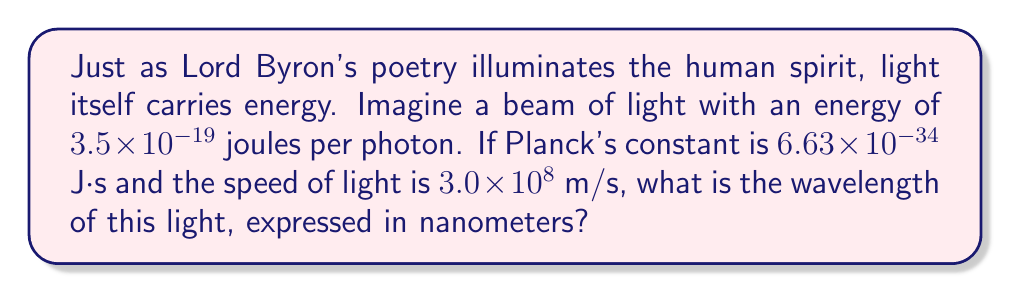Solve this math problem. Let's approach this step-by-step, much like we would analyze a poem:

1) We'll use the energy-frequency relationship, which is given by:
   $$E = hf$$
   where $E$ is energy, $h$ is Planck's constant, and $f$ is frequency.

2) We're given the energy $E = 3.5 \times 10^{-19}$ J, so let's solve for frequency:
   $$f = \frac{E}{h} = \frac{3.5 \times 10^{-19}}{6.63 \times 10^{-34}} = 5.28 \times 10^{14} \text{ Hz}$$

3) Now, we can use the wave equation to relate frequency to wavelength:
   $$c = f\lambda$$
   where $c$ is the speed of light and $\lambda$ is wavelength.

4) Rearranging to solve for wavelength:
   $$\lambda = \frac{c}{f} = \frac{3.0 \times 10^8}{5.28 \times 10^{14}} = 5.68 \times 10^{-7} \text{ m}$$

5) To convert this to nanometers, we multiply by $10^9$:
   $$5.68 \times 10^{-7} \text{ m} \times 10^9 \text{ nm/m} = 568 \text{ nm}$$

Thus, much like how Byron's words paint vivid images, this light paints the world in a specific hue corresponding to its wavelength.
Answer: 568 nm 